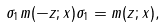<formula> <loc_0><loc_0><loc_500><loc_500>\sigma _ { 1 } m ( - z ; x ) \sigma _ { 1 } = m ( z ; x ) ,</formula> 